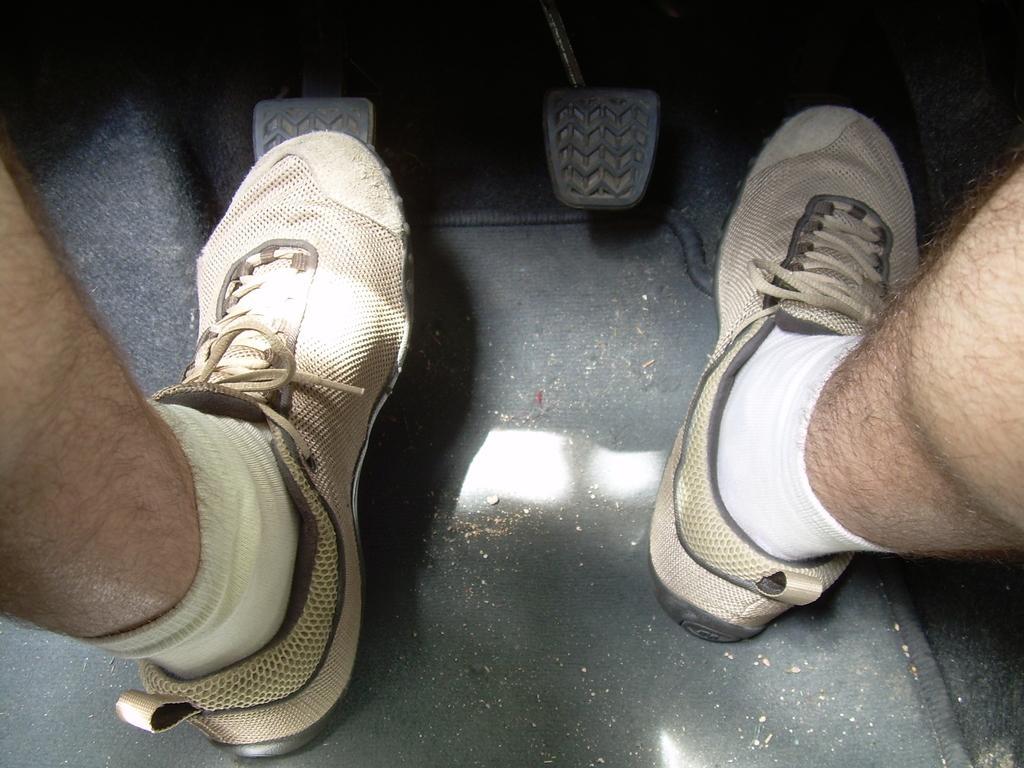Describe this image in one or two sentences. In this image we can see inside of a vehicle, there is a person's leg, there are socks, there are shoes, there is an acceleration towards the top of the image. 